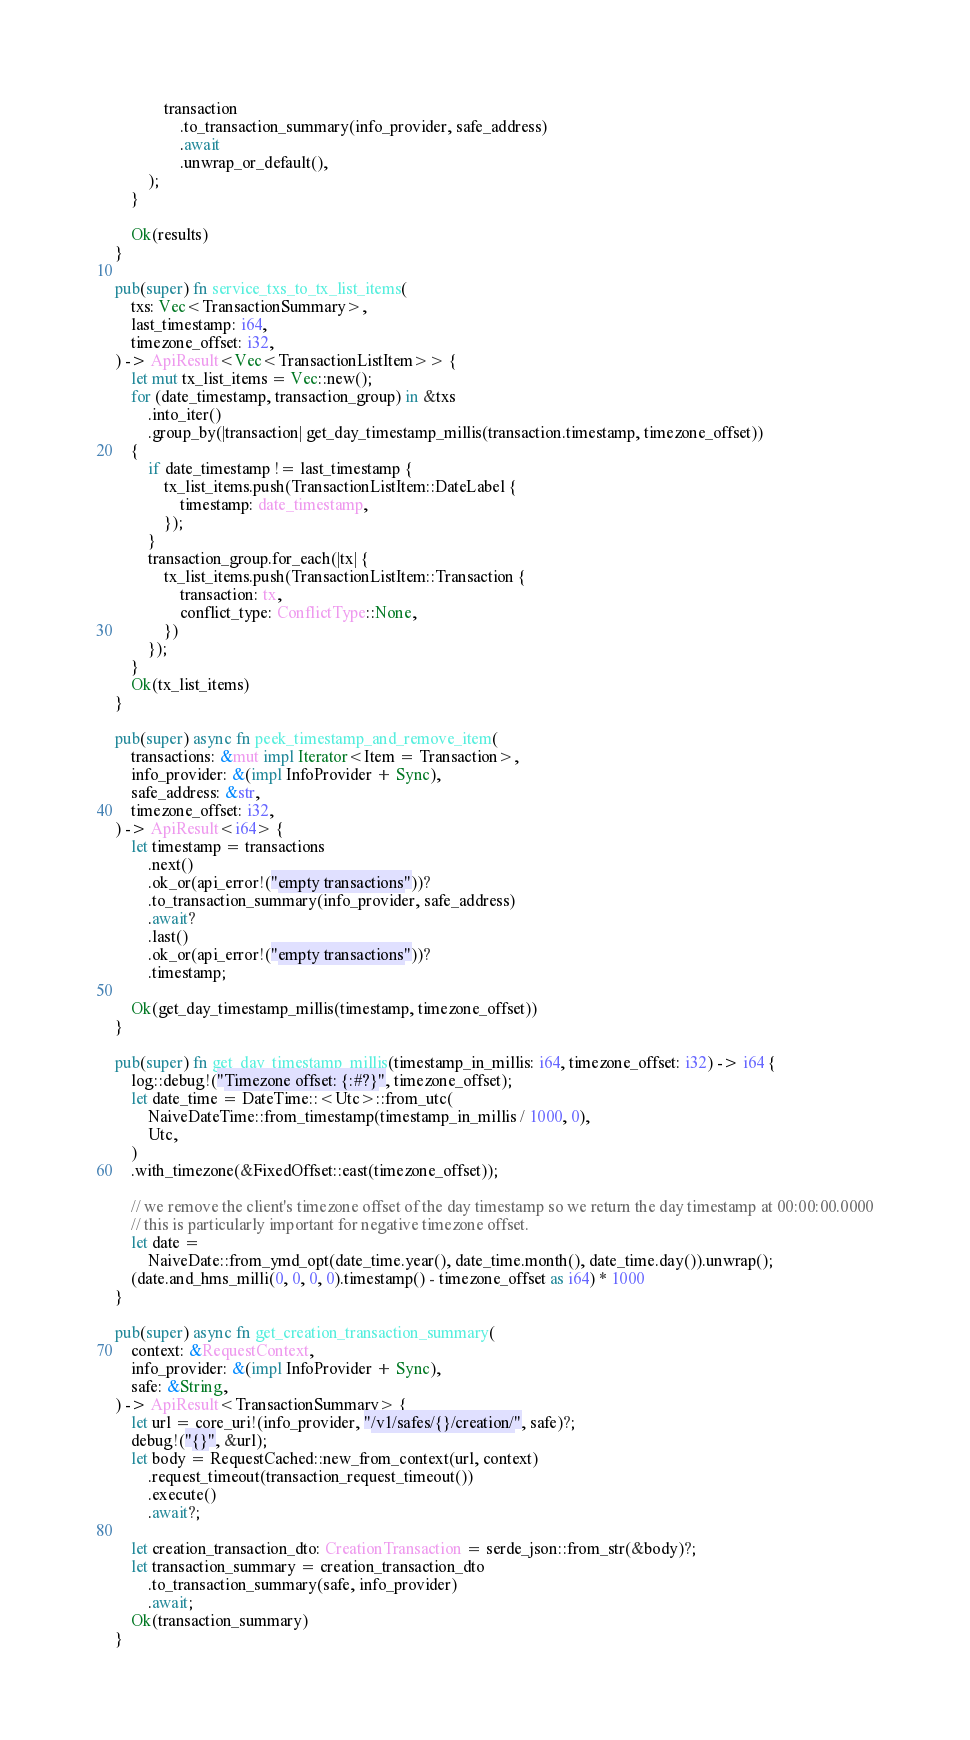<code> <loc_0><loc_0><loc_500><loc_500><_Rust_>            transaction
                .to_transaction_summary(info_provider, safe_address)
                .await
                .unwrap_or_default(),
        );
    }

    Ok(results)
}

pub(super) fn service_txs_to_tx_list_items(
    txs: Vec<TransactionSummary>,
    last_timestamp: i64,
    timezone_offset: i32,
) -> ApiResult<Vec<TransactionListItem>> {
    let mut tx_list_items = Vec::new();
    for (date_timestamp, transaction_group) in &txs
        .into_iter()
        .group_by(|transaction| get_day_timestamp_millis(transaction.timestamp, timezone_offset))
    {
        if date_timestamp != last_timestamp {
            tx_list_items.push(TransactionListItem::DateLabel {
                timestamp: date_timestamp,
            });
        }
        transaction_group.for_each(|tx| {
            tx_list_items.push(TransactionListItem::Transaction {
                transaction: tx,
                conflict_type: ConflictType::None,
            })
        });
    }
    Ok(tx_list_items)
}

pub(super) async fn peek_timestamp_and_remove_item(
    transactions: &mut impl Iterator<Item = Transaction>,
    info_provider: &(impl InfoProvider + Sync),
    safe_address: &str,
    timezone_offset: i32,
) -> ApiResult<i64> {
    let timestamp = transactions
        .next()
        .ok_or(api_error!("empty transactions"))?
        .to_transaction_summary(info_provider, safe_address)
        .await?
        .last()
        .ok_or(api_error!("empty transactions"))?
        .timestamp;

    Ok(get_day_timestamp_millis(timestamp, timezone_offset))
}

pub(super) fn get_day_timestamp_millis(timestamp_in_millis: i64, timezone_offset: i32) -> i64 {
    log::debug!("Timezone offset: {:#?}", timezone_offset);
    let date_time = DateTime::<Utc>::from_utc(
        NaiveDateTime::from_timestamp(timestamp_in_millis / 1000, 0),
        Utc,
    )
    .with_timezone(&FixedOffset::east(timezone_offset));

    // we remove the client's timezone offset of the day timestamp so we return the day timestamp at 00:00:00.0000
    // this is particularly important for negative timezone offset.
    let date =
        NaiveDate::from_ymd_opt(date_time.year(), date_time.month(), date_time.day()).unwrap();
    (date.and_hms_milli(0, 0, 0, 0).timestamp() - timezone_offset as i64) * 1000
}

pub(super) async fn get_creation_transaction_summary(
    context: &RequestContext,
    info_provider: &(impl InfoProvider + Sync),
    safe: &String,
) -> ApiResult<TransactionSummary> {
    let url = core_uri!(info_provider, "/v1/safes/{}/creation/", safe)?;
    debug!("{}", &url);
    let body = RequestCached::new_from_context(url, context)
        .request_timeout(transaction_request_timeout())
        .execute()
        .await?;

    let creation_transaction_dto: CreationTransaction = serde_json::from_str(&body)?;
    let transaction_summary = creation_transaction_dto
        .to_transaction_summary(safe, info_provider)
        .await;
    Ok(transaction_summary)
}
</code> 